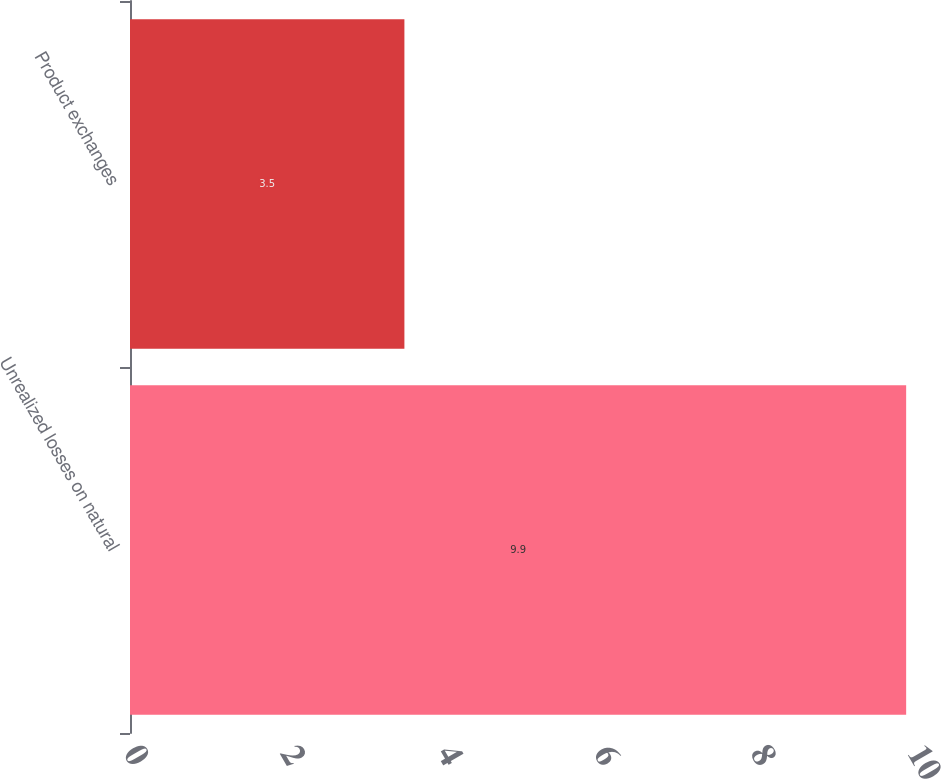Convert chart to OTSL. <chart><loc_0><loc_0><loc_500><loc_500><bar_chart><fcel>Unrealized losses on natural<fcel>Product exchanges<nl><fcel>9.9<fcel>3.5<nl></chart> 